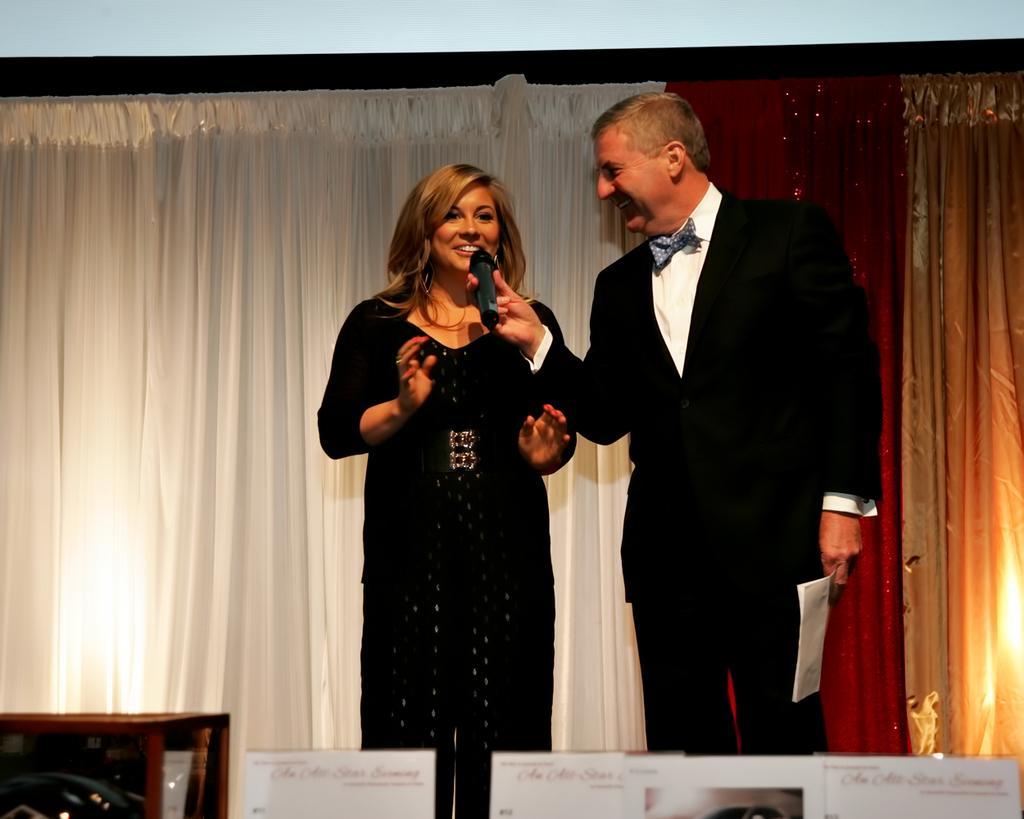Describe this image in one or two sentences. In this image there are two persons standing and smiling , a person holding a mike and a paper, and in the background there are curtains, boards. 